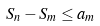Convert formula to latex. <formula><loc_0><loc_0><loc_500><loc_500>S _ { n } - S _ { m } \leq a _ { m }</formula> 